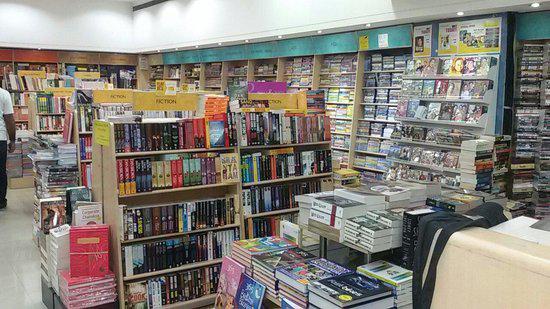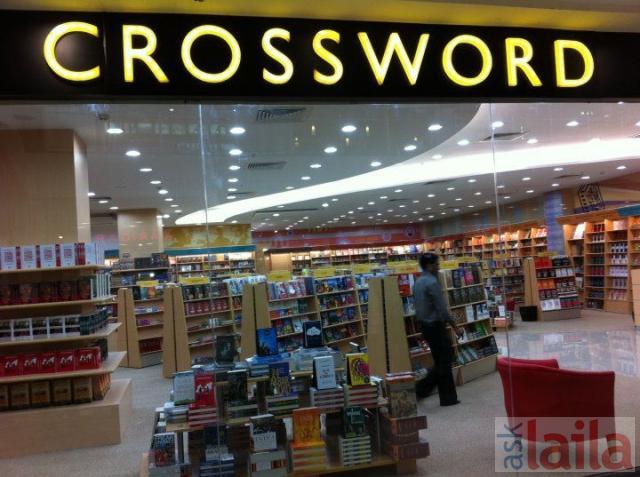The first image is the image on the left, the second image is the image on the right. Considering the images on both sides, is "The shops are empty." valid? Answer yes or no. No. The first image is the image on the left, the second image is the image on the right. For the images shown, is this caption "There is at least one person that is walking in a bookstore near a light brown bookshelf." true? Answer yes or no. Yes. 